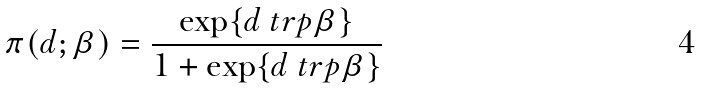Convert formula to latex. <formula><loc_0><loc_0><loc_500><loc_500>\pi ( d ; \beta ) = \frac { \exp \{ d \ t r p \beta \} } { 1 + \exp \{ d \ t r p \beta \} }</formula> 